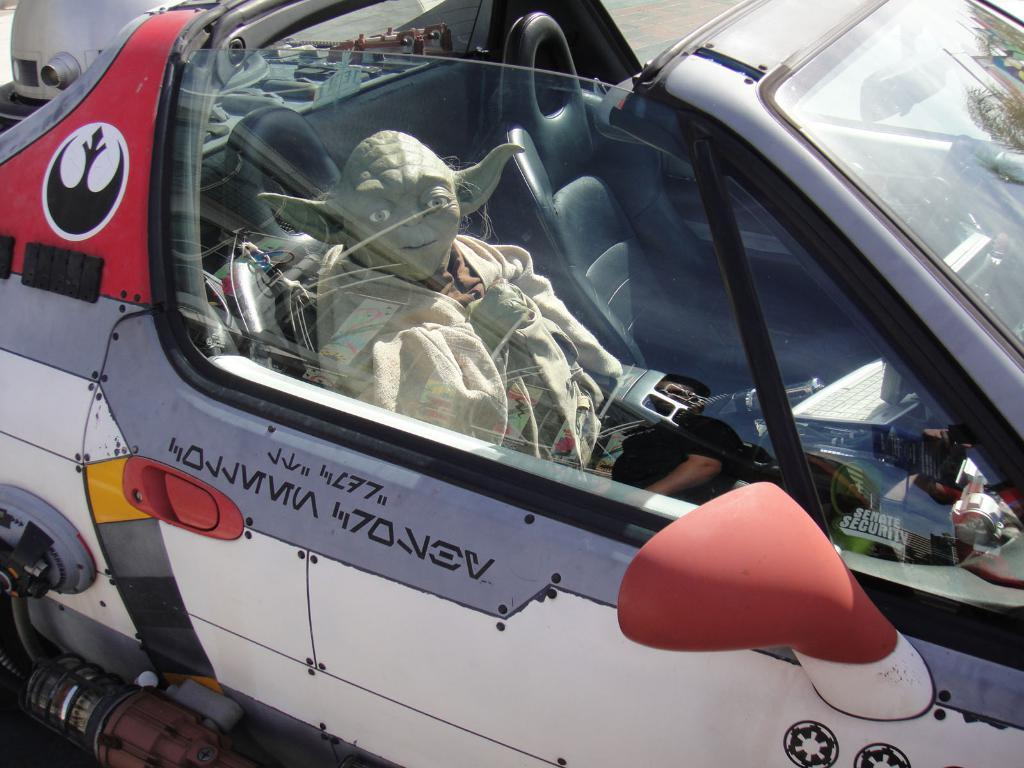What object is present in the image that is not a part of the car? There is a toy in the image. Where is the toy located in the image? The toy is placed in a car. What can be seen in the background of the image? There is a road visible in the background of the image. What type of apple can be seen growing on the side of the road in the image? There is no apple or any plant life visible in the image; it only features a toy in a car and a road in the background. 